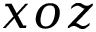Convert formula to latex. <formula><loc_0><loc_0><loc_500><loc_500>x o z</formula> 